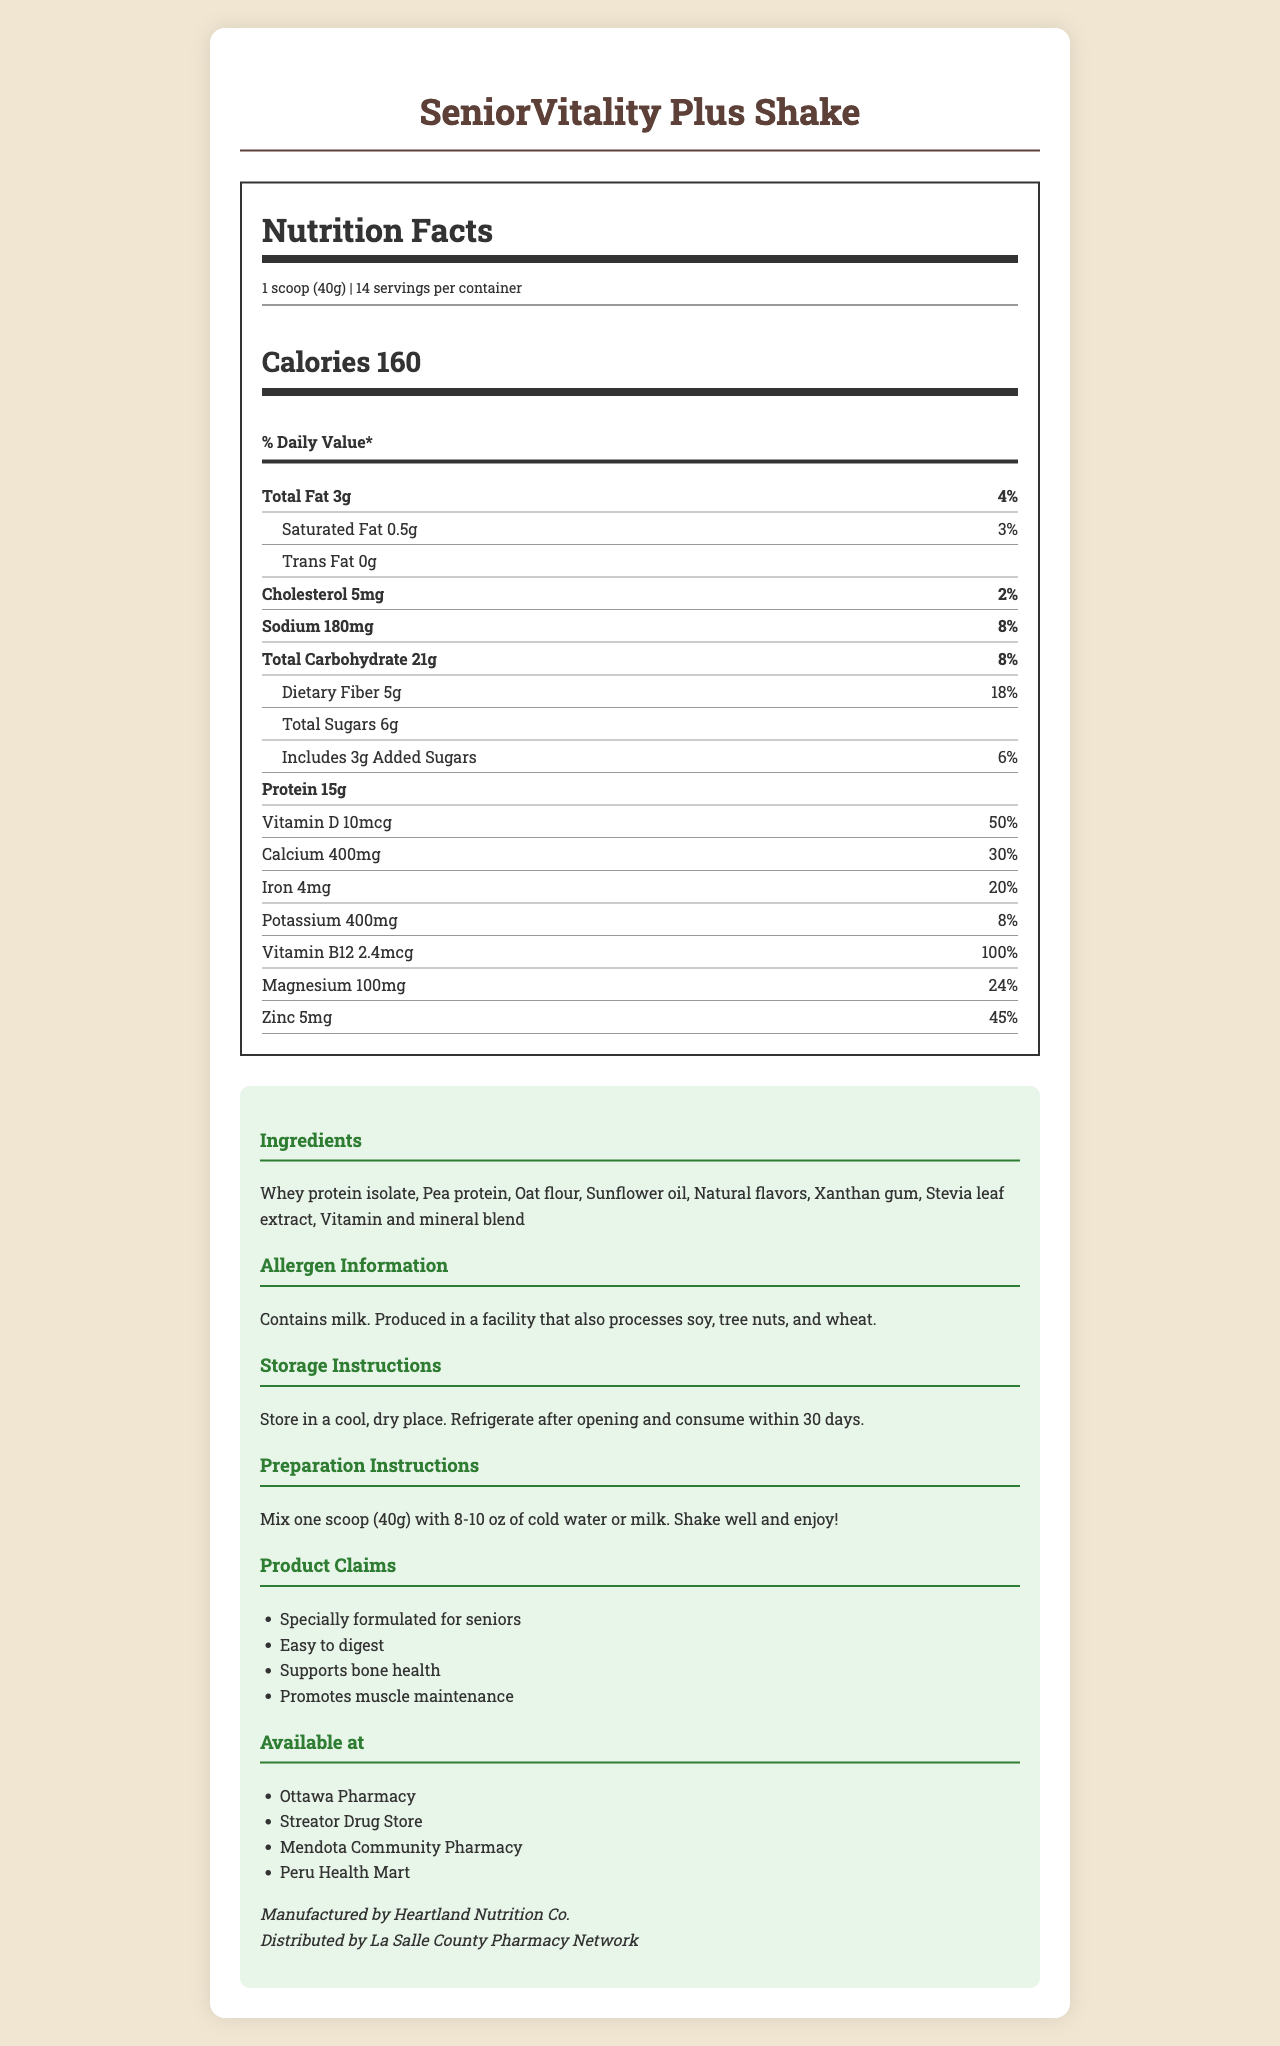What is the serving size for SeniorVitality Plus Shake? The serving size is clearly mentioned as 1 scoop (40g) in the document.
Answer: 1 scoop (40g) How many calories are there per serving of SeniorVitality Plus Shake? The calories per serving are listed as 160 in the Nutrition Facts section.
Answer: 160 calories What is the percentage of daily value for dietary fiber in the SeniorVitality Plus Shake? The document specifies that the dietary fiber has an 18% daily value.
Answer: 18% How much protein is in one serving of SeniorVitality Plus Shake? The amount of protein per serving is listed as 15g in the Nutrition Facts section.
Answer: 15g Which vitamin in the SeniorVitality Plus Shake provides 100% of the daily value? The document states that Vitamin B12 provides 100% of the daily value.
Answer: Vitamin B12 What ingredient in the SeniorVitality Plus Shake could cause allergies? The allergen information specifies that the product contains milk.
Answer: Milk How should you store the SeniorVitality Plus Shake after opening it? The storage instructions mention to refrigerate after opening and consume within 30 days.
Answer: Refrigerate after opening and consume within 30 days What is the amount of calcium per serving in the SeniorVitality Plus Shake? The amount of calcium per serving is listed as 400mg in the Nutrition Facts section.
Answer: 400mg Which of the following pharmacies does NOT carry the SeniorVitality Plus Shake? A. Ottawa Pharmacy B. Streator Drug Store C. La Salle Health Market D. Peru Health Mart The document lists the pharmacies that carry the product, and La Salle Health Market is not mentioned.
Answer: C. La Salle Health Market Which claim is NOT made about the SeniorVitality Plus Shake? A. Supports bone health B. Promotes heart health C. Easy to digest D. Specially formulated for seniors The claims listed include support for bone health, being easy to digest, and being specially formulated for seniors, but nothing about promoting heart health.
Answer: B. Promotes heart health Is there any trans fat in SeniorVitality Plus Shake? The document states there are 0g of trans fat.
Answer: No Summarize the main idea of the document. The document covers various aspects of the SeniorVitality Plus Shake, focusing on its nutritional content, usability, and availability.
Answer: The document is a Nutrition Facts label for the SeniorVitality Plus Shake, a meal replacement shake formulated for seniors. It provides detailed nutritional information, ingredients, allergen warnings, storage and preparation instructions, product claims, manufacturer and distributor information, and availability at local pharmacies. Who is the manufacturer of the SeniorVitality Plus Shake? The manufacturer information is listed as Heartland Nutrition Co.
Answer: Heartland Nutrition Co. Does the document provide information on the specific vitamins and minerals included in the "Vitamin and mineral blend" mentioned in the ingredients? The document lists "Vitamin and mineral blend" as an ingredient but does not provide specific details on which vitamins and minerals are included.
Answer: Not enough information 